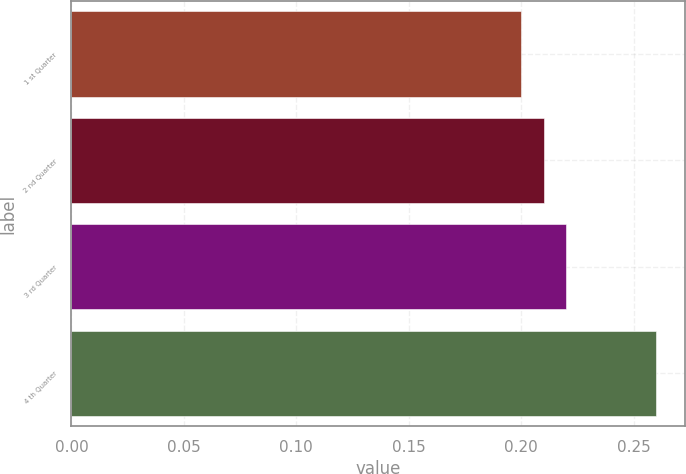<chart> <loc_0><loc_0><loc_500><loc_500><bar_chart><fcel>1 st Quarter<fcel>2 nd Quarter<fcel>3 rd Quarter<fcel>4 th Quarter<nl><fcel>0.2<fcel>0.21<fcel>0.22<fcel>0.26<nl></chart> 